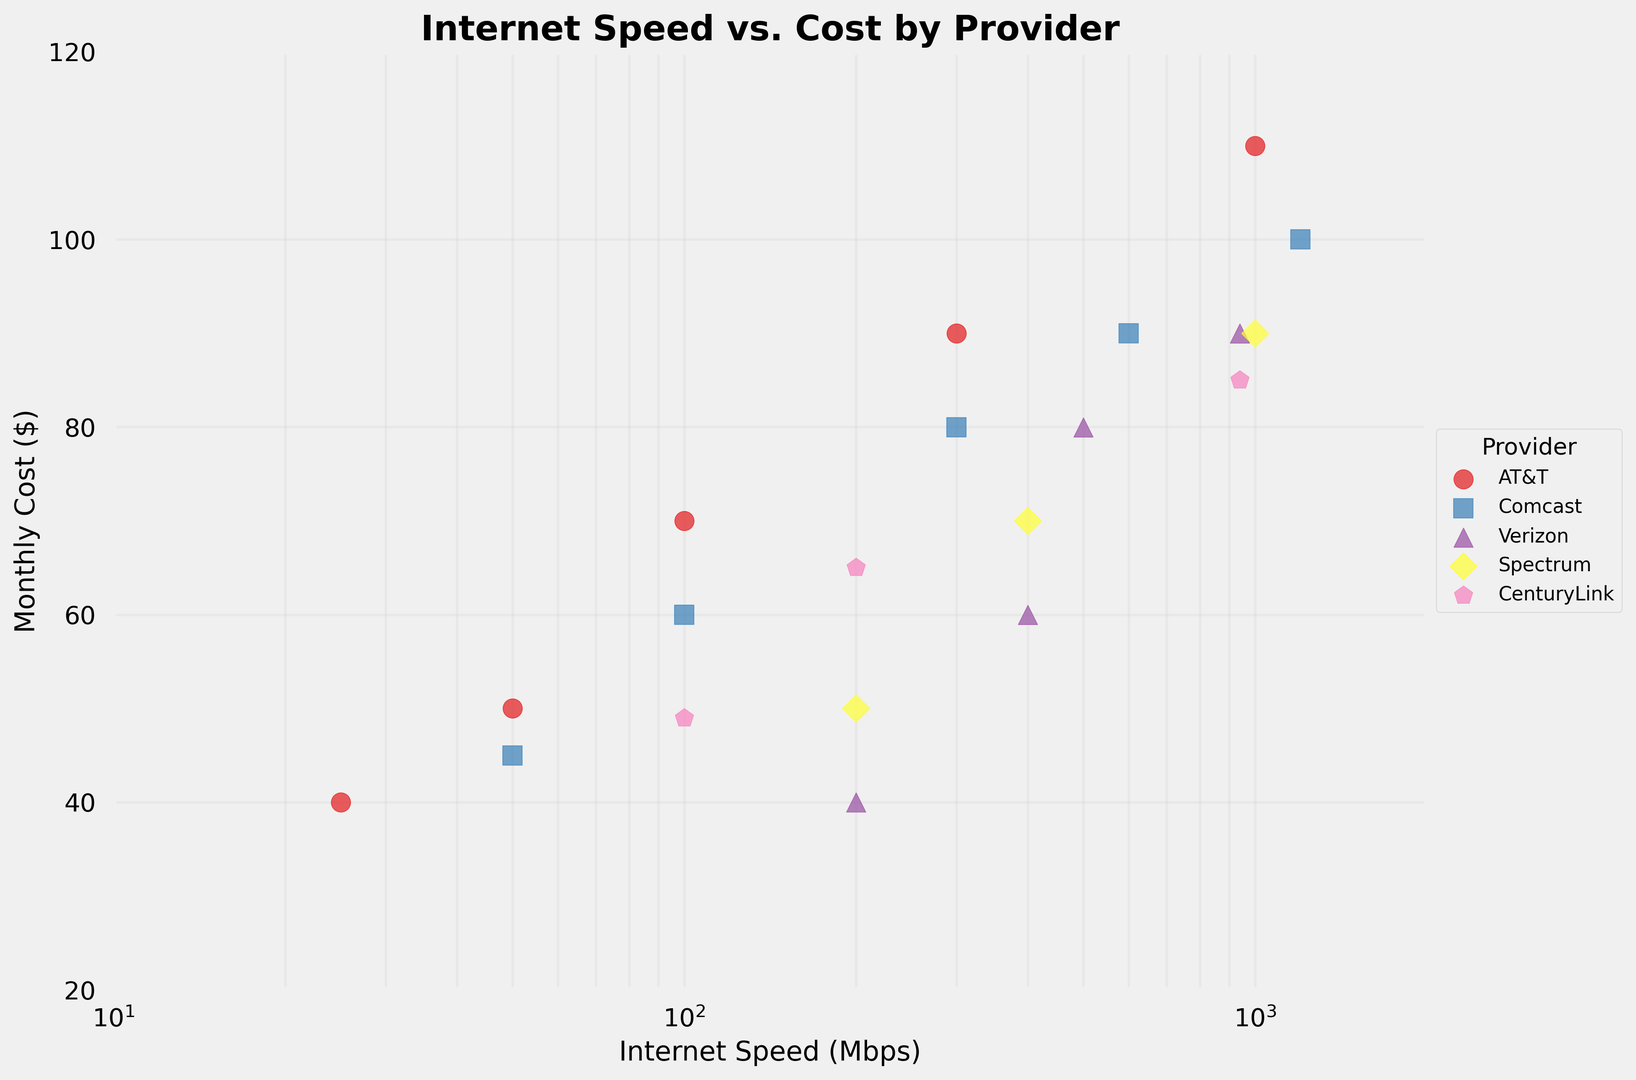What is the cost of Verizon's plan that offers the highest speed? First, identify Verizon's data points by the color and marker. The highest speed offered by Verizon is 940 Mbps, and the corresponding cost is visible next to that speed point.
Answer: $89.99 Which provider offers the cheapest plan for 100 Mbps? Check each provider's data points for a 100 Mbps plan and compare the costs. AT&T offers a plan for $69.99, Comcast for $59.99, CenturyLink for $49.00, and Cox for $59.99. CenturyLink offers the cheapest plan.
Answer: CenturyLink What is the price difference between Spectrum's 200 Mbps and 400 Mbps plans? Locate Spectrum's points for 200 Mbps and 400 Mbps. The costs are $49.99 and $69.99 respectively. Subtract the lower cost from the higher cost: $69.99 - $49.99.
Answer: $20.00 How many providers offer plans with speeds of at least 1000 Mbps? Identify the data points that represent speeds of 1000 Mbps or more. AT&T, Comcast, Spectrum, CenturyLink, and Cox each offer such plans. Count these providers.
Answer: 5 What is the least expensive plan for speeds of at least 200 Mbps? Identify points corresponding to speeds of 200 Mbps or more and compare their costs. Verizon's 200 Mbps plan costs $39.99, which is the least expensive.
Answer: $39.99 Is AT&T's highest speed plan more expensive than Comcast's highest speed plan? Look at the highest speed plans for AT&T and Comcast. AT&T's highest is 1000 Mbps at $109.99 and Comcast's highest is 1200 Mbps at $99.99. Compare the costs.
Answer: Yes What is the average cost of CenturyLink's three plans? Locate all CenturyLink points: 100 Mbps for $49.00, 200 Mbps for $65.00, and 940 Mbps for $85.00. Calculate the average by summing these costs and dividing by 3: ($49.00 + $65.00 + $85.00) / 3.
Answer: $66.33 Which provider offers the most cost-effective plan for 500 Mbps? Compare the costs of 500 Mbps plans. Verizon offers 500 Mbps for $79.99 and Cox offers it for $79.99. Neither has a cheaper option; both are equally cost-effective.
Answer: Verizon/Cox How much more does AT&T's 300 Mbps plan cost compared to its 100 Mbps plan? Identify AT&T's points for 300 Mbps and 100 Mbps. The costs are $89.99 and $69.99, respectively. Calculate the difference: $89.99 - $69.99.
Answer: $20.00 Which provider has the lowest cost for a 400 Mbps plan? Identify all 400 Mbps plans and compare their costs. Spectrum offers it for $69.99 and Verizon offers it for $59.99. Verizon is the lowest.
Answer: Verizon 